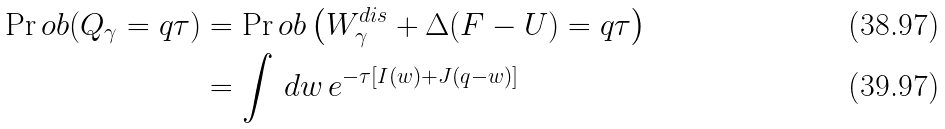Convert formula to latex. <formula><loc_0><loc_0><loc_500><loc_500>\Pr o b ( Q _ { \gamma } = q \tau ) & = \Pr o b \left ( W _ { \gamma } ^ { d i s } + \Delta ( F - U ) = q \tau \right ) \\ & = \int \, d w \, e ^ { - \tau [ I ( w ) + J ( q - w ) ] }</formula> 